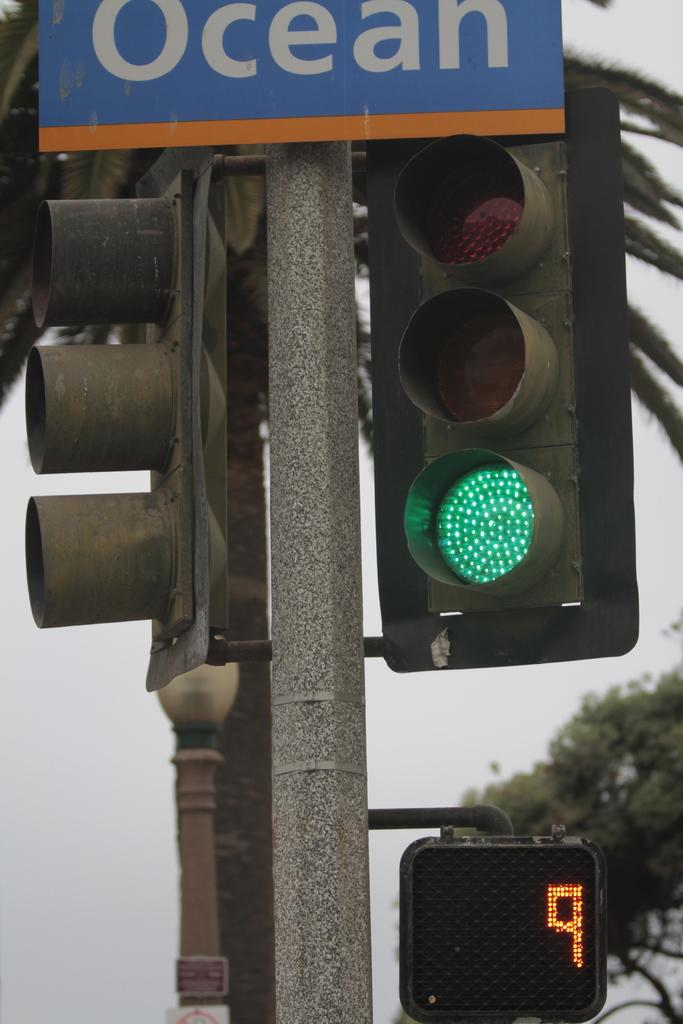<image>
Present a compact description of the photo's key features. a close up of a sign for OCEAN by traffic lights 